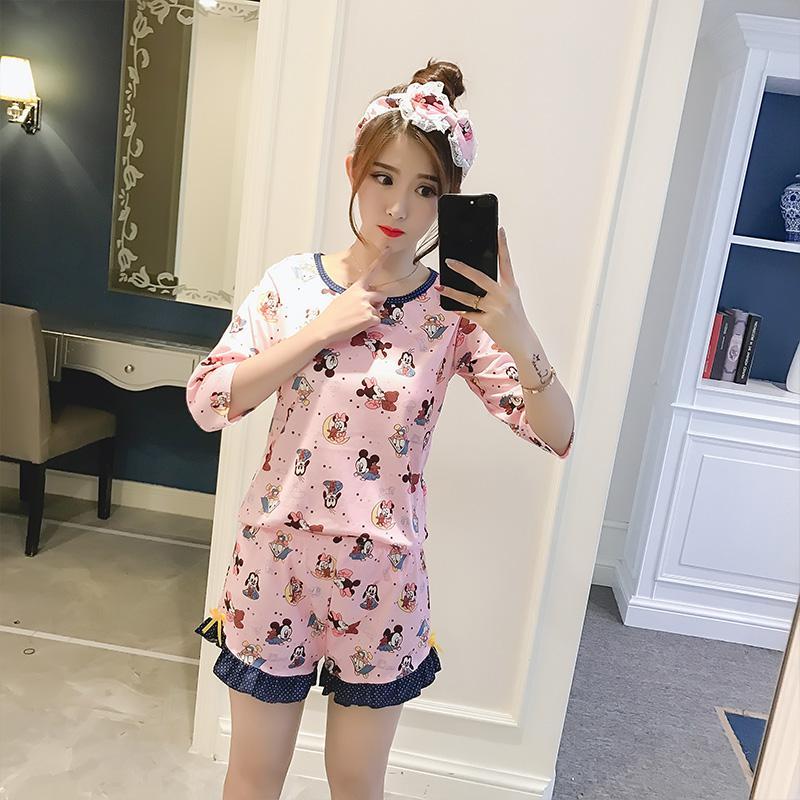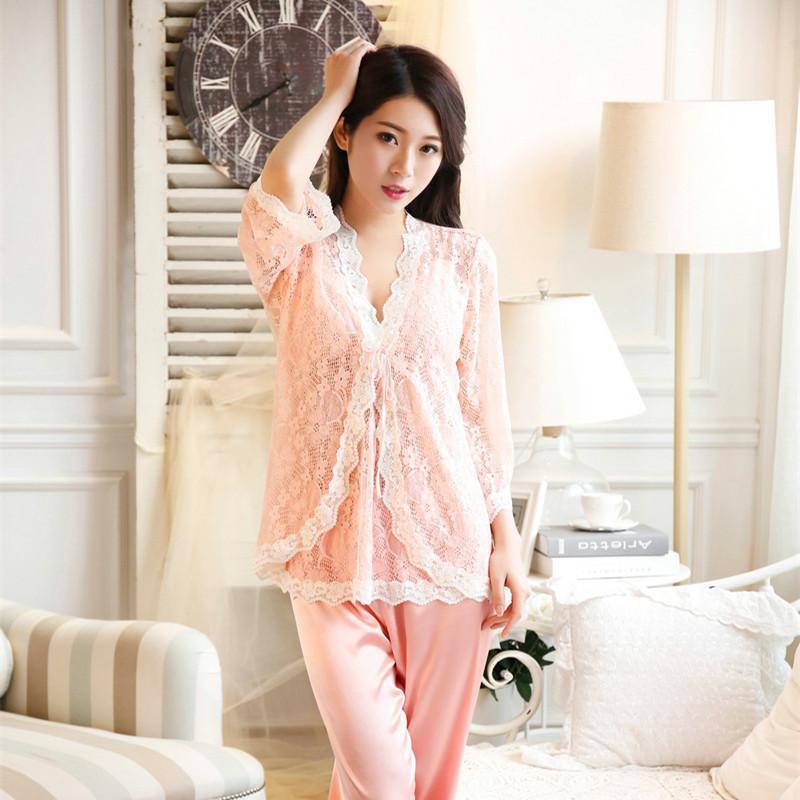The first image is the image on the left, the second image is the image on the right. Assess this claim about the two images: "A model wears a pajama shorts set patterned all over with cute animals.". Correct or not? Answer yes or no. Yes. The first image is the image on the left, the second image is the image on the right. Evaluate the accuracy of this statement regarding the images: "There is a lamp behind a girl wearing pajamas.". Is it true? Answer yes or no. Yes. 